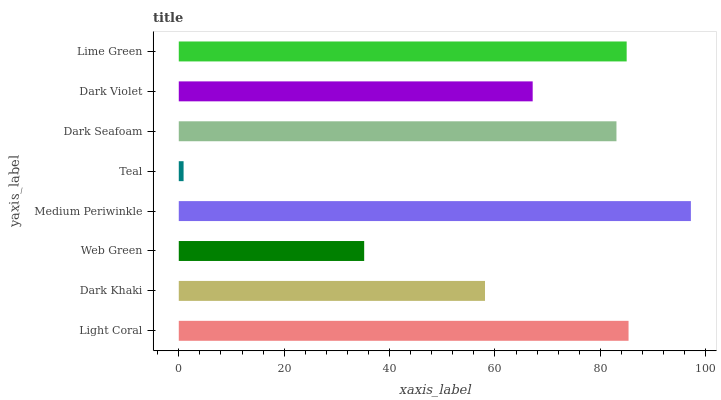Is Teal the minimum?
Answer yes or no. Yes. Is Medium Periwinkle the maximum?
Answer yes or no. Yes. Is Dark Khaki the minimum?
Answer yes or no. No. Is Dark Khaki the maximum?
Answer yes or no. No. Is Light Coral greater than Dark Khaki?
Answer yes or no. Yes. Is Dark Khaki less than Light Coral?
Answer yes or no. Yes. Is Dark Khaki greater than Light Coral?
Answer yes or no. No. Is Light Coral less than Dark Khaki?
Answer yes or no. No. Is Dark Seafoam the high median?
Answer yes or no. Yes. Is Dark Violet the low median?
Answer yes or no. Yes. Is Lime Green the high median?
Answer yes or no. No. Is Web Green the low median?
Answer yes or no. No. 